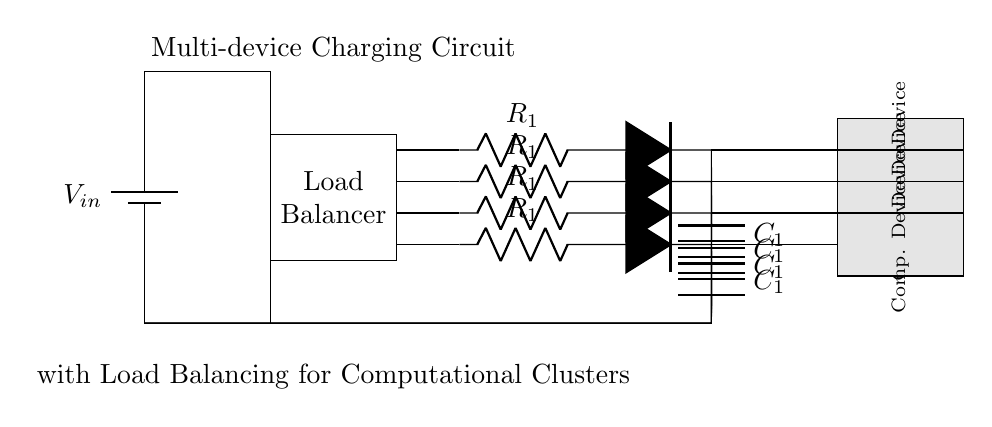What is the type of power source used in this circuit? The circuit employs a battery as its power source, as indicated by the symbol. The battery is labeled as V_in, which represents the input voltage supplied to the circuit.
Answer: battery How many computational devices are being charged in this circuit? There are four computational devices represented in the diagram, situated in the lower right area of the circuit. Each device has a gray rectangle, indicating they are separate components connected to the charging circuit.
Answer: four What is the purpose of the load balancer in this circuit? The load balancer is designed to distribute the input voltage and current evenly among the connected devices. This ensures that each device receives an appropriate amount of power to operate efficiently, preventing any single device from overloading.
Answer: distribute power Which component provides the resistance in the charging circuits? The resistors, denoted as R_1 in the circuit, are responsible for providing resistance within each charging branch. Each charging circuit includes one resistor that impacts the current flowing to the connected devices.
Answer: R1 What kind of capacitors are used in this charging circuit? The circuit employs capacitors represented by the symbol C_1, which are used to store electrical energy and smooth out fluctuations in the voltage supplied to the devices. This stabilization is crucial for maintaining reliable performance of the devices being charged.
Answer: C1 How does the circuit achieve effective load balancing? Load balancing is accomplished through the integration of the load balancer component, which controls the distribution of incoming voltage to prevent any single computational device from drawing excessive current, ensuring equal charging rates across all devices. This helps optimize performance and prolongs device lifespan.
Answer: load balancer 